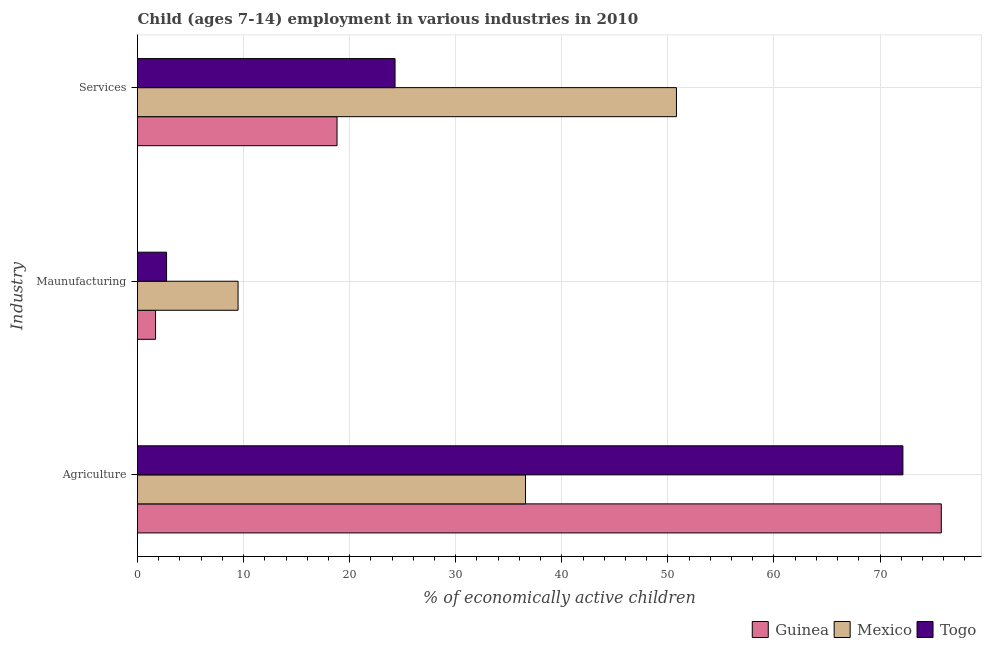How many groups of bars are there?
Make the answer very short. 3. Are the number of bars per tick equal to the number of legend labels?
Your answer should be compact. Yes. Are the number of bars on each tick of the Y-axis equal?
Offer a terse response. Yes. How many bars are there on the 2nd tick from the top?
Keep it short and to the point. 3. How many bars are there on the 3rd tick from the bottom?
Offer a terse response. 3. What is the label of the 2nd group of bars from the top?
Offer a very short reply. Maunufacturing. What is the percentage of economically active children in services in Togo?
Provide a short and direct response. 24.28. Across all countries, what is the maximum percentage of economically active children in agriculture?
Ensure brevity in your answer.  75.78. In which country was the percentage of economically active children in manufacturing maximum?
Offer a terse response. Mexico. In which country was the percentage of economically active children in agriculture minimum?
Provide a succinct answer. Mexico. What is the total percentage of economically active children in agriculture in the graph?
Keep it short and to the point. 184.52. What is the difference between the percentage of economically active children in agriculture in Guinea and that in Mexico?
Provide a succinct answer. 39.2. What is the difference between the percentage of economically active children in services in Mexico and the percentage of economically active children in manufacturing in Togo?
Give a very brief answer. 48.07. What is the average percentage of economically active children in manufacturing per country?
Give a very brief answer. 4.64. What is the difference between the percentage of economically active children in agriculture and percentage of economically active children in manufacturing in Mexico?
Keep it short and to the point. 27.1. What is the ratio of the percentage of economically active children in services in Guinea to that in Mexico?
Ensure brevity in your answer.  0.37. What is the difference between the highest and the second highest percentage of economically active children in services?
Your answer should be very brief. 26.53. What is the difference between the highest and the lowest percentage of economically active children in manufacturing?
Offer a terse response. 7.78. What does the 2nd bar from the top in Services represents?
Provide a succinct answer. Mexico. How many bars are there?
Give a very brief answer. 9. Are all the bars in the graph horizontal?
Provide a succinct answer. Yes. How many countries are there in the graph?
Offer a terse response. 3. What is the difference between two consecutive major ticks on the X-axis?
Provide a short and direct response. 10. Are the values on the major ticks of X-axis written in scientific E-notation?
Offer a terse response. No. Does the graph contain any zero values?
Make the answer very short. No. Does the graph contain grids?
Your answer should be very brief. Yes. Where does the legend appear in the graph?
Your answer should be very brief. Bottom right. How many legend labels are there?
Offer a very short reply. 3. How are the legend labels stacked?
Provide a short and direct response. Horizontal. What is the title of the graph?
Offer a terse response. Child (ages 7-14) employment in various industries in 2010. What is the label or title of the X-axis?
Your answer should be very brief. % of economically active children. What is the label or title of the Y-axis?
Give a very brief answer. Industry. What is the % of economically active children of Guinea in Agriculture?
Your answer should be very brief. 75.78. What is the % of economically active children in Mexico in Agriculture?
Make the answer very short. 36.58. What is the % of economically active children in Togo in Agriculture?
Offer a terse response. 72.16. What is the % of economically active children of Mexico in Maunufacturing?
Give a very brief answer. 9.48. What is the % of economically active children of Togo in Maunufacturing?
Ensure brevity in your answer.  2.74. What is the % of economically active children in Guinea in Services?
Ensure brevity in your answer.  18.81. What is the % of economically active children in Mexico in Services?
Offer a very short reply. 50.81. What is the % of economically active children in Togo in Services?
Your answer should be compact. 24.28. Across all Industry, what is the maximum % of economically active children in Guinea?
Offer a very short reply. 75.78. Across all Industry, what is the maximum % of economically active children of Mexico?
Your answer should be compact. 50.81. Across all Industry, what is the maximum % of economically active children of Togo?
Ensure brevity in your answer.  72.16. Across all Industry, what is the minimum % of economically active children of Guinea?
Give a very brief answer. 1.7. Across all Industry, what is the minimum % of economically active children in Mexico?
Give a very brief answer. 9.48. Across all Industry, what is the minimum % of economically active children in Togo?
Offer a very short reply. 2.74. What is the total % of economically active children in Guinea in the graph?
Provide a succinct answer. 96.29. What is the total % of economically active children in Mexico in the graph?
Your answer should be very brief. 96.87. What is the total % of economically active children in Togo in the graph?
Make the answer very short. 99.18. What is the difference between the % of economically active children in Guinea in Agriculture and that in Maunufacturing?
Provide a short and direct response. 74.08. What is the difference between the % of economically active children of Mexico in Agriculture and that in Maunufacturing?
Offer a terse response. 27.1. What is the difference between the % of economically active children of Togo in Agriculture and that in Maunufacturing?
Ensure brevity in your answer.  69.42. What is the difference between the % of economically active children of Guinea in Agriculture and that in Services?
Keep it short and to the point. 56.97. What is the difference between the % of economically active children of Mexico in Agriculture and that in Services?
Give a very brief answer. -14.23. What is the difference between the % of economically active children of Togo in Agriculture and that in Services?
Your response must be concise. 47.88. What is the difference between the % of economically active children in Guinea in Maunufacturing and that in Services?
Give a very brief answer. -17.11. What is the difference between the % of economically active children in Mexico in Maunufacturing and that in Services?
Offer a very short reply. -41.33. What is the difference between the % of economically active children of Togo in Maunufacturing and that in Services?
Your response must be concise. -21.54. What is the difference between the % of economically active children in Guinea in Agriculture and the % of economically active children in Mexico in Maunufacturing?
Give a very brief answer. 66.3. What is the difference between the % of economically active children of Guinea in Agriculture and the % of economically active children of Togo in Maunufacturing?
Your answer should be compact. 73.04. What is the difference between the % of economically active children of Mexico in Agriculture and the % of economically active children of Togo in Maunufacturing?
Give a very brief answer. 33.84. What is the difference between the % of economically active children in Guinea in Agriculture and the % of economically active children in Mexico in Services?
Make the answer very short. 24.97. What is the difference between the % of economically active children of Guinea in Agriculture and the % of economically active children of Togo in Services?
Your response must be concise. 51.5. What is the difference between the % of economically active children in Guinea in Maunufacturing and the % of economically active children in Mexico in Services?
Make the answer very short. -49.11. What is the difference between the % of economically active children of Guinea in Maunufacturing and the % of economically active children of Togo in Services?
Your answer should be very brief. -22.58. What is the difference between the % of economically active children of Mexico in Maunufacturing and the % of economically active children of Togo in Services?
Offer a terse response. -14.8. What is the average % of economically active children in Guinea per Industry?
Provide a succinct answer. 32.1. What is the average % of economically active children of Mexico per Industry?
Provide a succinct answer. 32.29. What is the average % of economically active children in Togo per Industry?
Offer a very short reply. 33.06. What is the difference between the % of economically active children of Guinea and % of economically active children of Mexico in Agriculture?
Provide a short and direct response. 39.2. What is the difference between the % of economically active children in Guinea and % of economically active children in Togo in Agriculture?
Ensure brevity in your answer.  3.62. What is the difference between the % of economically active children in Mexico and % of economically active children in Togo in Agriculture?
Offer a very short reply. -35.58. What is the difference between the % of economically active children in Guinea and % of economically active children in Mexico in Maunufacturing?
Provide a succinct answer. -7.78. What is the difference between the % of economically active children in Guinea and % of economically active children in Togo in Maunufacturing?
Offer a terse response. -1.04. What is the difference between the % of economically active children in Mexico and % of economically active children in Togo in Maunufacturing?
Your answer should be compact. 6.74. What is the difference between the % of economically active children in Guinea and % of economically active children in Mexico in Services?
Offer a very short reply. -32. What is the difference between the % of economically active children in Guinea and % of economically active children in Togo in Services?
Make the answer very short. -5.47. What is the difference between the % of economically active children of Mexico and % of economically active children of Togo in Services?
Your response must be concise. 26.53. What is the ratio of the % of economically active children in Guinea in Agriculture to that in Maunufacturing?
Provide a short and direct response. 44.58. What is the ratio of the % of economically active children in Mexico in Agriculture to that in Maunufacturing?
Provide a short and direct response. 3.86. What is the ratio of the % of economically active children of Togo in Agriculture to that in Maunufacturing?
Provide a short and direct response. 26.34. What is the ratio of the % of economically active children of Guinea in Agriculture to that in Services?
Offer a terse response. 4.03. What is the ratio of the % of economically active children in Mexico in Agriculture to that in Services?
Ensure brevity in your answer.  0.72. What is the ratio of the % of economically active children of Togo in Agriculture to that in Services?
Keep it short and to the point. 2.97. What is the ratio of the % of economically active children in Guinea in Maunufacturing to that in Services?
Ensure brevity in your answer.  0.09. What is the ratio of the % of economically active children in Mexico in Maunufacturing to that in Services?
Provide a short and direct response. 0.19. What is the ratio of the % of economically active children of Togo in Maunufacturing to that in Services?
Offer a terse response. 0.11. What is the difference between the highest and the second highest % of economically active children of Guinea?
Give a very brief answer. 56.97. What is the difference between the highest and the second highest % of economically active children of Mexico?
Give a very brief answer. 14.23. What is the difference between the highest and the second highest % of economically active children of Togo?
Your answer should be compact. 47.88. What is the difference between the highest and the lowest % of economically active children of Guinea?
Ensure brevity in your answer.  74.08. What is the difference between the highest and the lowest % of economically active children in Mexico?
Provide a succinct answer. 41.33. What is the difference between the highest and the lowest % of economically active children of Togo?
Offer a terse response. 69.42. 